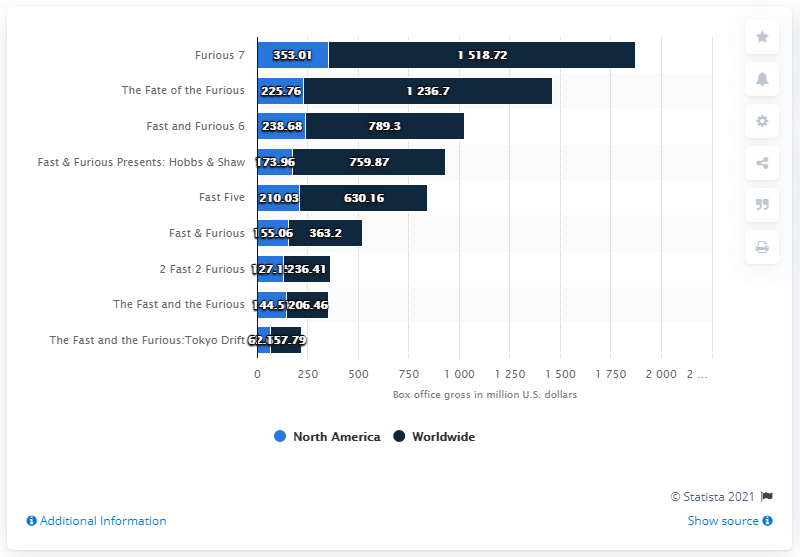Outline some significant characteristics in this image. The box office gross worldwide for 'Furious 7' was 1518.72. The gross of "Furious 7" in theaters across North America in September 2020 was 353.01. 